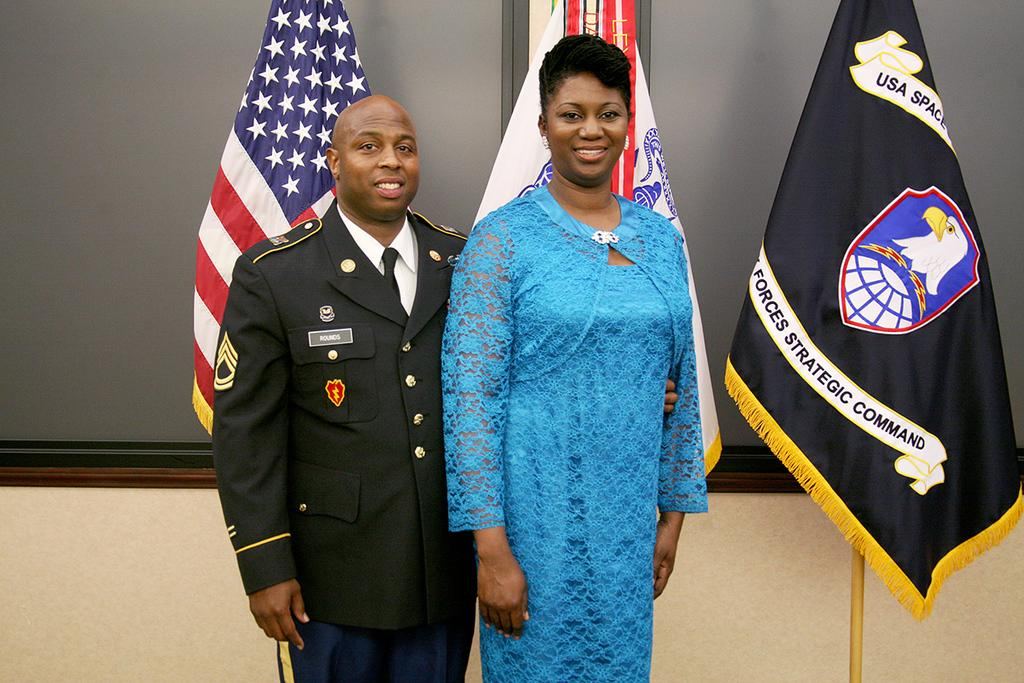<image>
Give a short and clear explanation of the subsequent image. A man in military uniform named Rounds stands with a lady in a blue dress in from of the American Flag and a US Space Forces flag. 